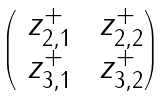<formula> <loc_0><loc_0><loc_500><loc_500>\begin{pmatrix} \ z _ { 2 , 1 } ^ { + } & \ z _ { 2 , 2 } ^ { + } \\ \ z _ { 3 , 1 } ^ { + } & \ z _ { 3 , 2 } ^ { + } \end{pmatrix}</formula> 